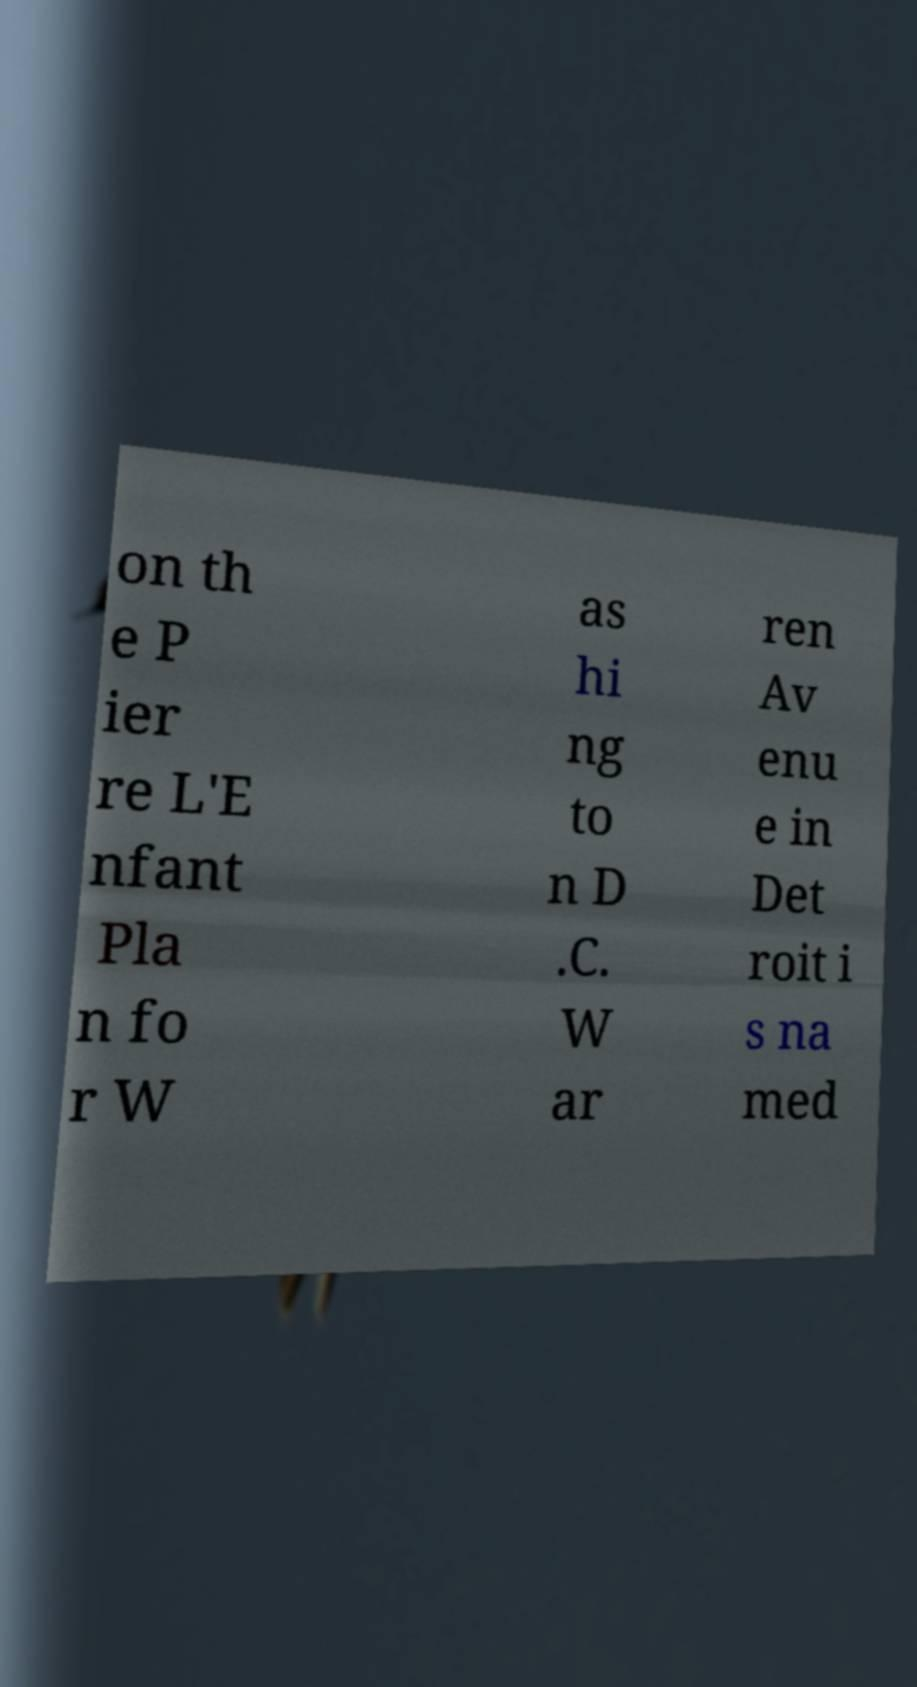I need the written content from this picture converted into text. Can you do that? on th e P ier re L'E nfant Pla n fo r W as hi ng to n D .C. W ar ren Av enu e in Det roit i s na med 